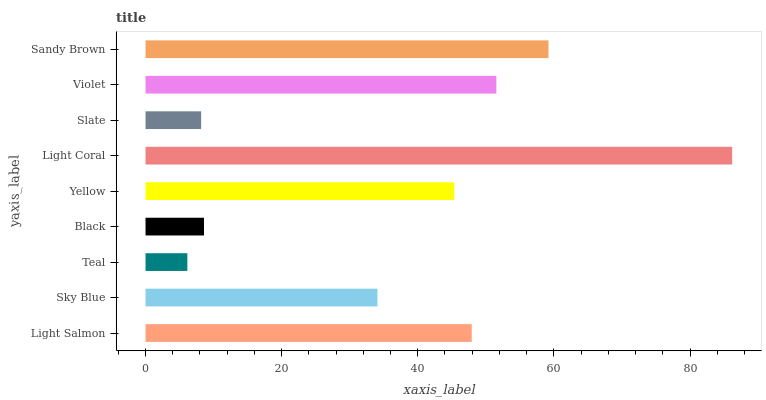Is Teal the minimum?
Answer yes or no. Yes. Is Light Coral the maximum?
Answer yes or no. Yes. Is Sky Blue the minimum?
Answer yes or no. No. Is Sky Blue the maximum?
Answer yes or no. No. Is Light Salmon greater than Sky Blue?
Answer yes or no. Yes. Is Sky Blue less than Light Salmon?
Answer yes or no. Yes. Is Sky Blue greater than Light Salmon?
Answer yes or no. No. Is Light Salmon less than Sky Blue?
Answer yes or no. No. Is Yellow the high median?
Answer yes or no. Yes. Is Yellow the low median?
Answer yes or no. Yes. Is Black the high median?
Answer yes or no. No. Is Light Coral the low median?
Answer yes or no. No. 